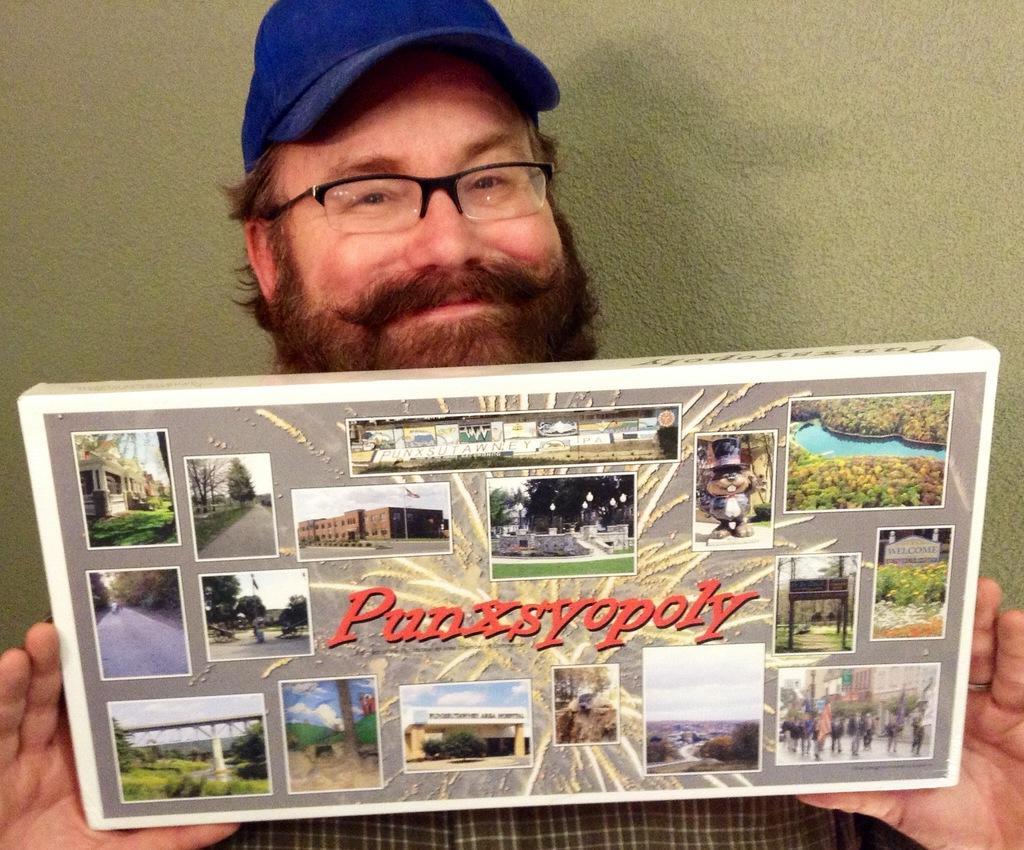How would you summarize this image in a sentence or two? Here we can see a man holding a frame with his hands. He has spectacles and he is smiling. In the background there is a wall. 